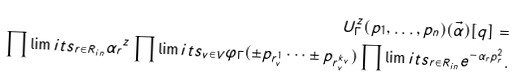<formula> <loc_0><loc_0><loc_500><loc_500>U ^ { z } _ { \Gamma } ( p _ { 1 } , \dots , p _ { n } ) ( \vec { \alpha } ) [ q ] = \\ \prod \lim i t s _ { r \in R _ { i n } } { \alpha _ { r } } ^ { z } \prod \lim i t s _ { v \in V } \varphi _ { \Gamma } ( \pm p _ { r _ { v } ^ { 1 } } \dots \pm p _ { r _ { v } ^ { k _ { v } } } ) \prod \lim i t s _ { r \in R _ { i n } } e ^ { - \alpha _ { r } { p } ^ { 2 } _ { r } } .</formula> 